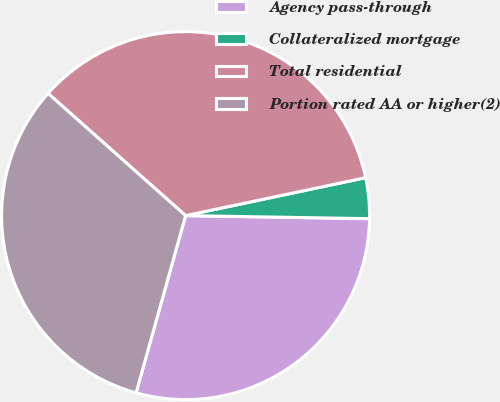Convert chart to OTSL. <chart><loc_0><loc_0><loc_500><loc_500><pie_chart><fcel>Agency pass-through<fcel>Collateralized mortgage<fcel>Total residential<fcel>Portion rated AA or higher(2)<nl><fcel>29.07%<fcel>3.57%<fcel>35.13%<fcel>32.22%<nl></chart> 